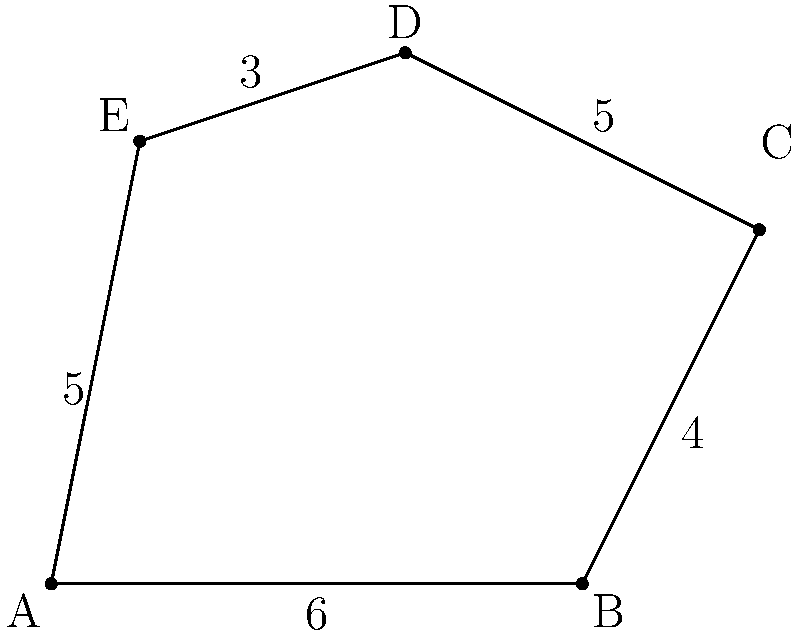In Flowerdale, an irregular pentagonal plot of historical significance has been discovered. The plot's vertices are labeled A, B, C, D, and E, with side lengths as shown in the diagram. Calculate the area of this historical land plot using the method of dividing it into triangles. To calculate the area of this irregular pentagon, we can divide it into three triangles: ABC, ACD, and ADE. We'll use Heron's formula to calculate the area of each triangle and then sum them up.

1. Triangle ABC:
   Semi-perimeter $s_1 = \frac{6 + 4 + 8}{2} = 9$
   Area $A_1 = \sqrt{9(9-6)(9-4)(9-8)} = \sqrt{9 \cdot 3 \cdot 5 \cdot 1} = \sqrt{135} \approx 11.62$

2. Triangle ACD:
   We need to find AC first using the Pythagorean theorem:
   $AC = \sqrt{6^2 + 4^2} = \sqrt{52} \approx 7.21$
   Semi-perimeter $s_2 = \frac{7.21 + 5 + 4}{2} = 8.105$
   Area $A_2 = \sqrt{8.105(8.105-7.21)(8.105-5)(8.105-4)} \approx 11.98$

3. Triangle ADE:
   Semi-perimeter $s_3 = \frac{5 + 3 + 5}{2} = 6.5$
   Area $A_3 = \sqrt{6.5(6.5-5)(6.5-3)(6.5-5)} = \sqrt{6.5 \cdot 1.5 \cdot 3.5 \cdot 1.5} \approx 6.50$

Total area = $A_1 + A_2 + A_3 \approx 11.62 + 11.98 + 6.50 = 30.10$ square units.
Answer: $30.10$ square units 